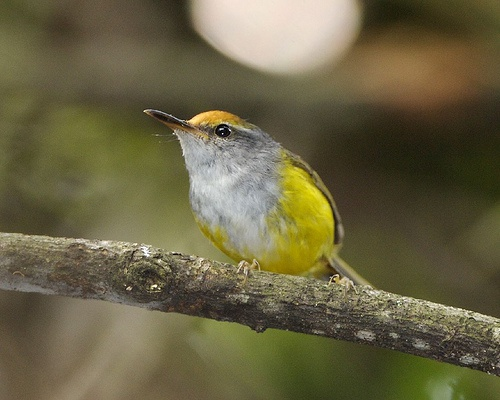Describe the objects in this image and their specific colors. I can see a bird in darkgreen, darkgray, and olive tones in this image. 